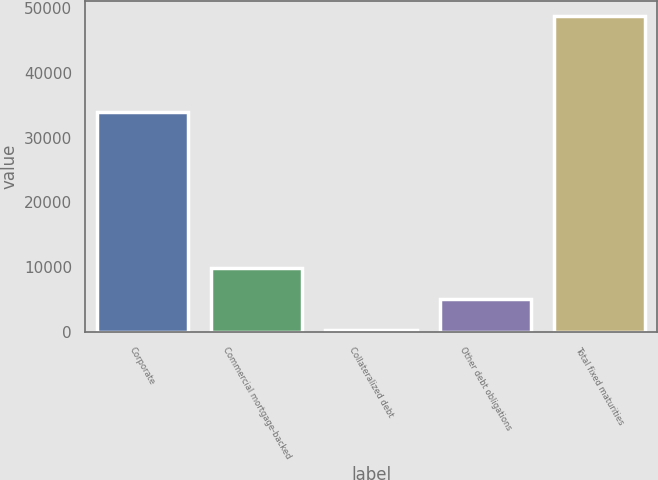Convert chart. <chart><loc_0><loc_0><loc_500><loc_500><bar_chart><fcel>Corporate<fcel>Commercial mortgage-backed<fcel>Collateralized debt<fcel>Other debt obligations<fcel>Total fixed maturities<nl><fcel>33892.5<fcel>9961.66<fcel>293<fcel>5127.33<fcel>48636.3<nl></chart> 